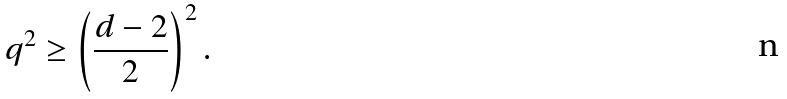Convert formula to latex. <formula><loc_0><loc_0><loc_500><loc_500>q ^ { 2 } \geq \left ( \frac { d - 2 } { 2 } \right ) ^ { 2 } .</formula> 